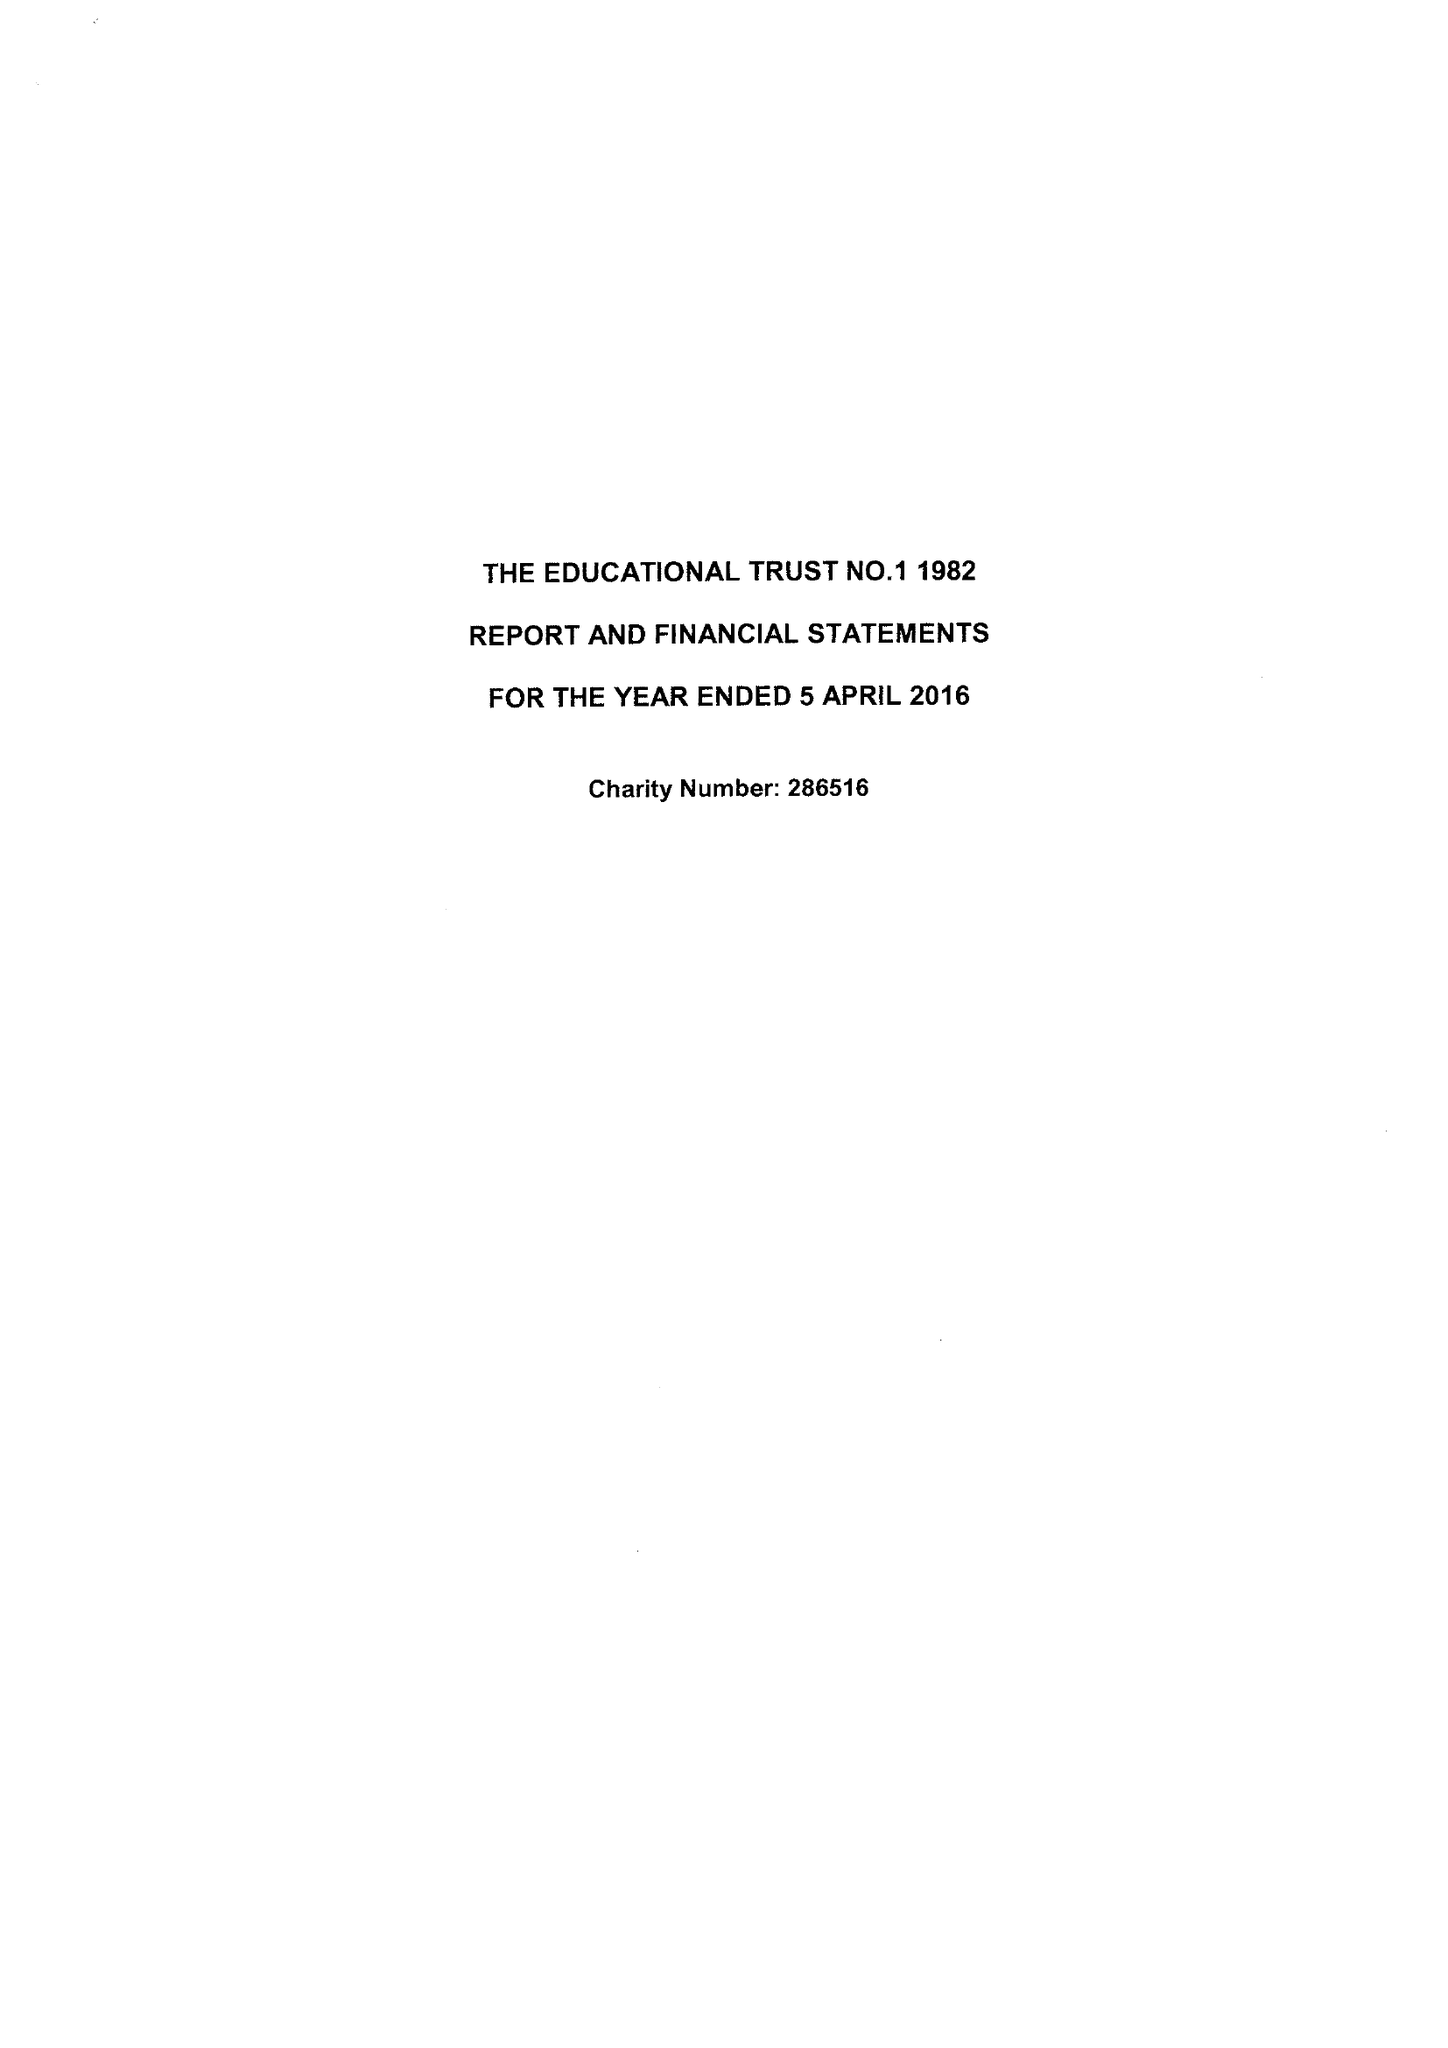What is the value for the income_annually_in_british_pounds?
Answer the question using a single word or phrase. 929093.00 